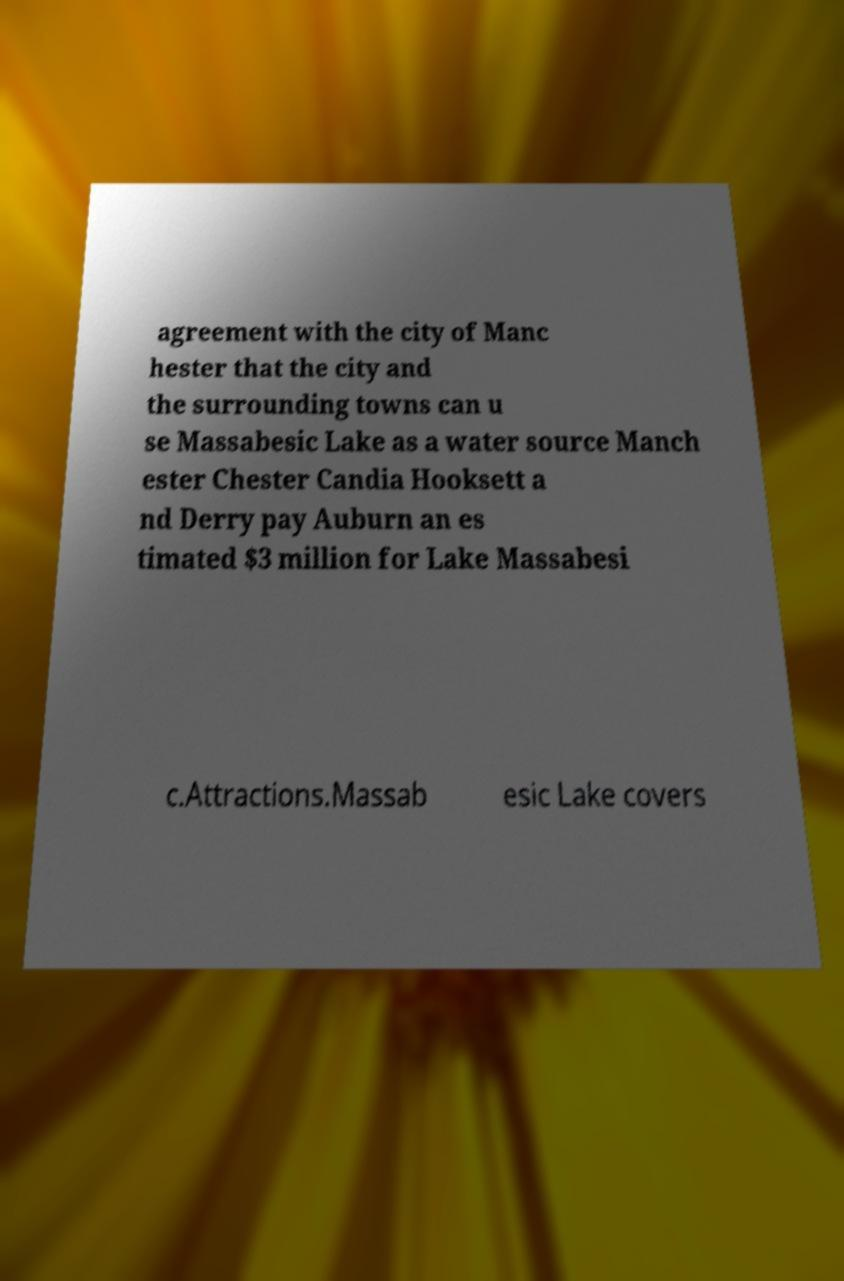Please read and relay the text visible in this image. What does it say? agreement with the city of Manc hester that the city and the surrounding towns can u se Massabesic Lake as a water source Manch ester Chester Candia Hooksett a nd Derry pay Auburn an es timated $3 million for Lake Massabesi c.Attractions.Massab esic Lake covers 